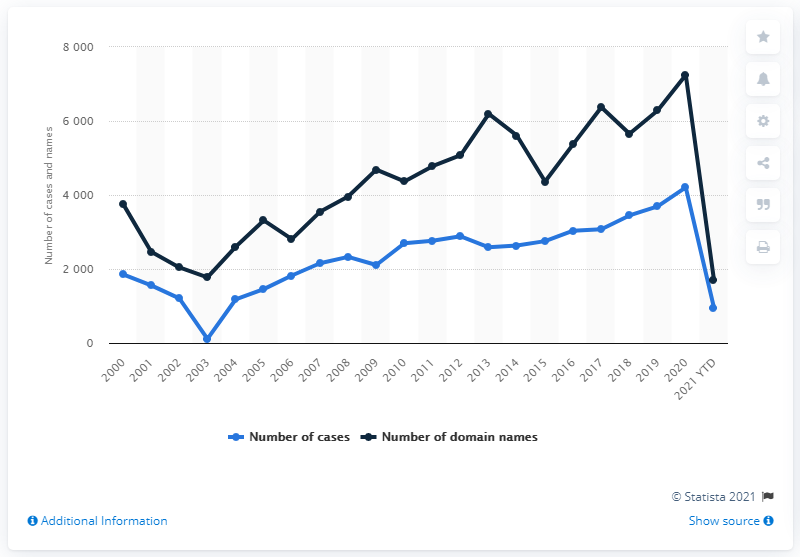Point out several critical features in this image. In the year 2016, a total of 958 cybersquatting cases were filed with the World Intellectual Property Organization. 